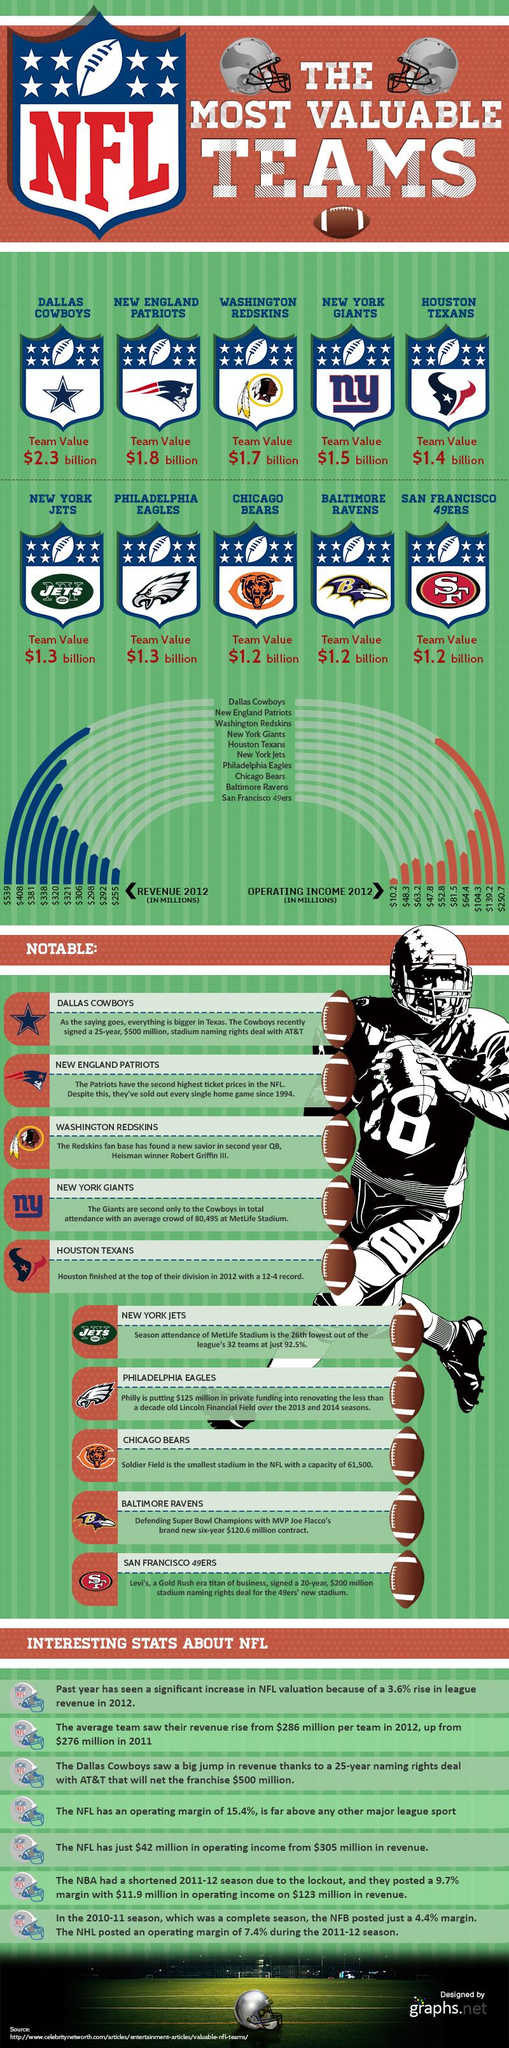Highlight a few significant elements in this photo. The Dallas Cowboys have the highest value franchise in the National Football League. The estimated value of the Washington Redskins football team is $1.7 billion. In 2012, the operating income of the Chicago Bears was $63.2 million. The San Francisco 49ers generated the least revenue among all NFL teams in 2012. In 2012, the New York Giants generated approximately $338 million in revenue. 